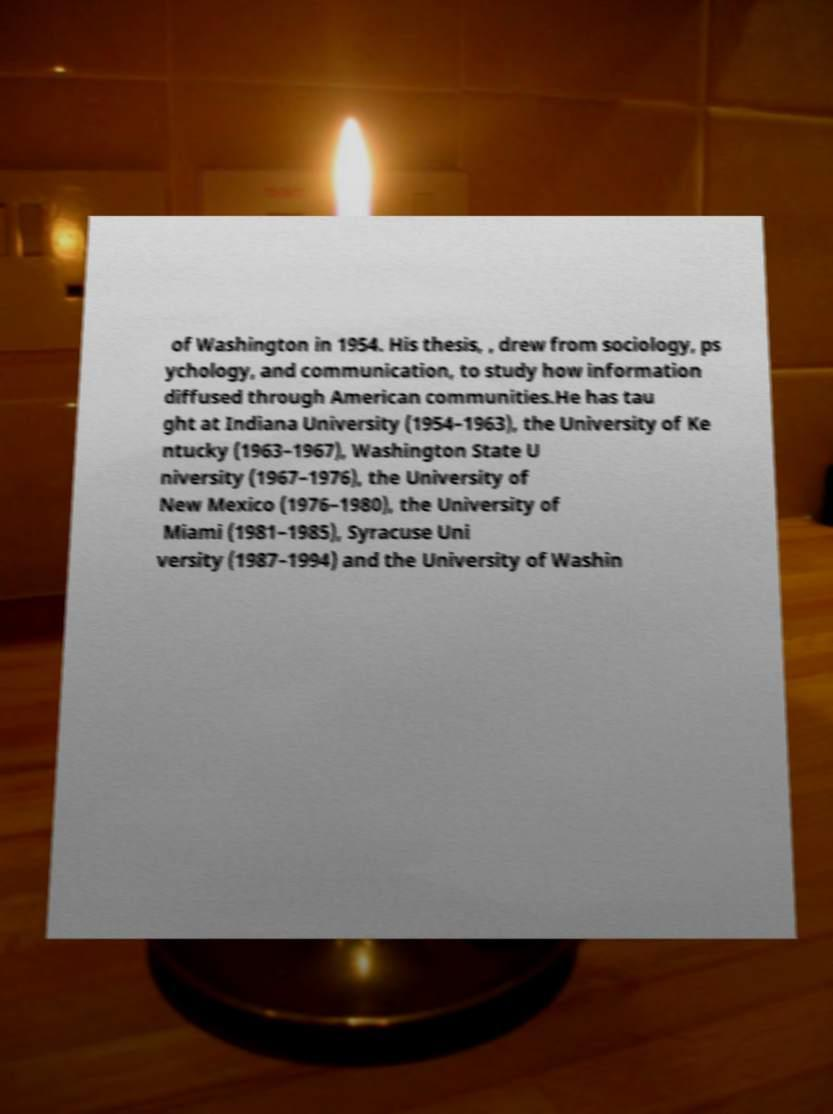Could you extract and type out the text from this image? of Washington in 1954. His thesis, , drew from sociology, ps ychology, and communication, to study how information diffused through American communities.He has tau ght at Indiana University (1954–1963), the University of Ke ntucky (1963–1967), Washington State U niversity (1967–1976), the University of New Mexico (1976–1980), the University of Miami (1981–1985), Syracuse Uni versity (1987–1994) and the University of Washin 